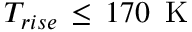<formula> <loc_0><loc_0><loc_500><loc_500>T _ { r i s e } \, \leq \, 1 7 0 \, K</formula> 